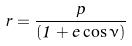Convert formula to latex. <formula><loc_0><loc_0><loc_500><loc_500>r = \frac { p } { ( 1 + e \cos \nu ) }</formula> 